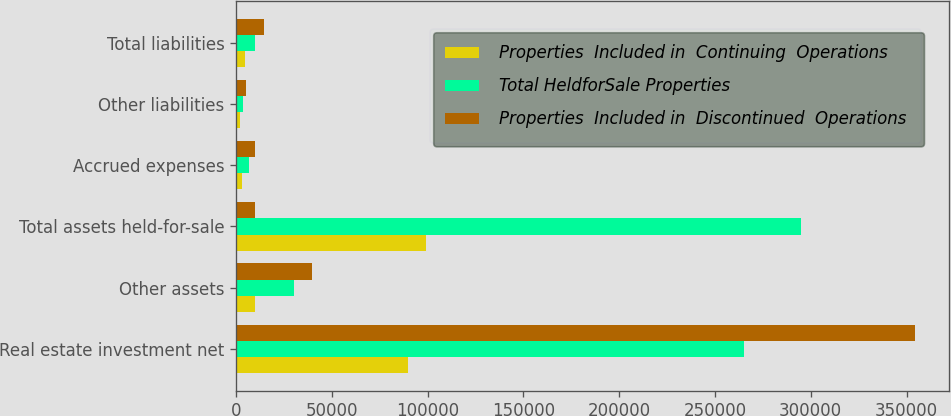Convert chart. <chart><loc_0><loc_0><loc_500><loc_500><stacked_bar_chart><ecel><fcel>Real estate investment net<fcel>Other assets<fcel>Total assets held-for-sale<fcel>Accrued expenses<fcel>Other liabilities<fcel>Total liabilities<nl><fcel>Properties  Included in  Continuing  Operations<fcel>89643<fcel>9557<fcel>99200<fcel>2936<fcel>1789<fcel>4725<nl><fcel>Total HeldforSale Properties<fcel>265049<fcel>30038<fcel>295087<fcel>6679<fcel>3328<fcel>10007<nl><fcel>Properties  Included in  Discontinued  Operations<fcel>354692<fcel>39595<fcel>10007<fcel>9615<fcel>5117<fcel>14732<nl></chart> 